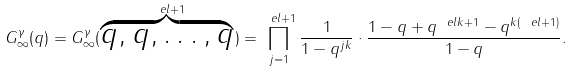<formula> <loc_0><loc_0><loc_500><loc_500>G ^ { \gamma } _ { \infty } ( q ) = G ^ { \gamma } _ { \infty } ( \overbrace { q , q , \dots , q } ^ { \ e l + 1 } ) = \prod _ { j = 1 } ^ { \ e l + 1 } \frac { 1 } { 1 - q ^ { j k } } \cdot \frac { 1 - q + q ^ { \ e l k + 1 } - q ^ { k ( \ e l + 1 ) } } { 1 - q } .</formula> 